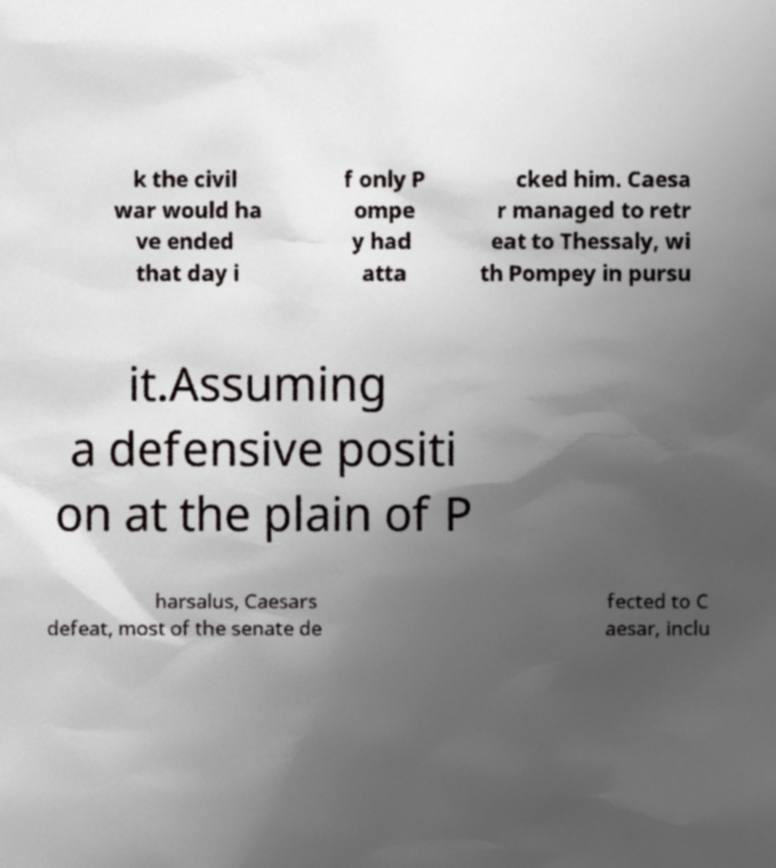What messages or text are displayed in this image? I need them in a readable, typed format. k the civil war would ha ve ended that day i f only P ompe y had atta cked him. Caesa r managed to retr eat to Thessaly, wi th Pompey in pursu it.Assuming a defensive positi on at the plain of P harsalus, Caesars defeat, most of the senate de fected to C aesar, inclu 